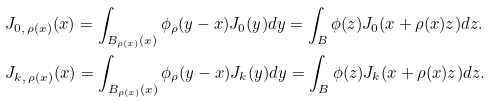Convert formula to latex. <formula><loc_0><loc_0><loc_500><loc_500>& J _ { 0 , \, \rho ( x ) } ( x ) = \int _ { B _ { \rho ( x ) } ( x ) } \phi _ { \rho } ( y - x ) J _ { 0 } ( y ) d y = \int _ { B } \phi ( z ) J _ { 0 } ( x + \rho ( x ) z ) d z . \\ & J _ { k , \, \rho ( x ) } ( x ) = \int _ { B _ { \rho ( x ) } ( x ) } \phi _ { \rho } ( y - x ) J _ { k } ( y ) d y = \int _ { B } \phi ( z ) J _ { k } ( x + \rho ( x ) z ) d z .</formula> 